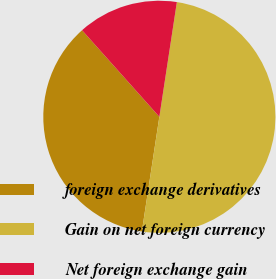<chart> <loc_0><loc_0><loc_500><loc_500><pie_chart><fcel>foreign exchange derivatives<fcel>Gain on net foreign currency<fcel>Net foreign exchange gain<nl><fcel>35.99%<fcel>50.0%<fcel>14.01%<nl></chart> 